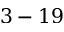Convert formula to latex. <formula><loc_0><loc_0><loc_500><loc_500>3 - 1 9</formula> 